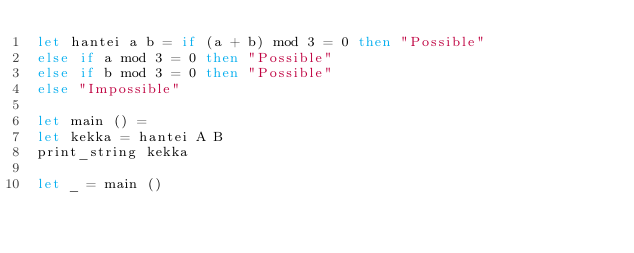<code> <loc_0><loc_0><loc_500><loc_500><_OCaml_>let hantei a b = if (a + b) mod 3 = 0 then "Possible"
else if a mod 3 = 0 then "Possible"
else if b mod 3 = 0 then "Possible"
else "Impossible"

let main () =
let kekka = hantei A B
print_string kekka

let _ = main ()</code> 